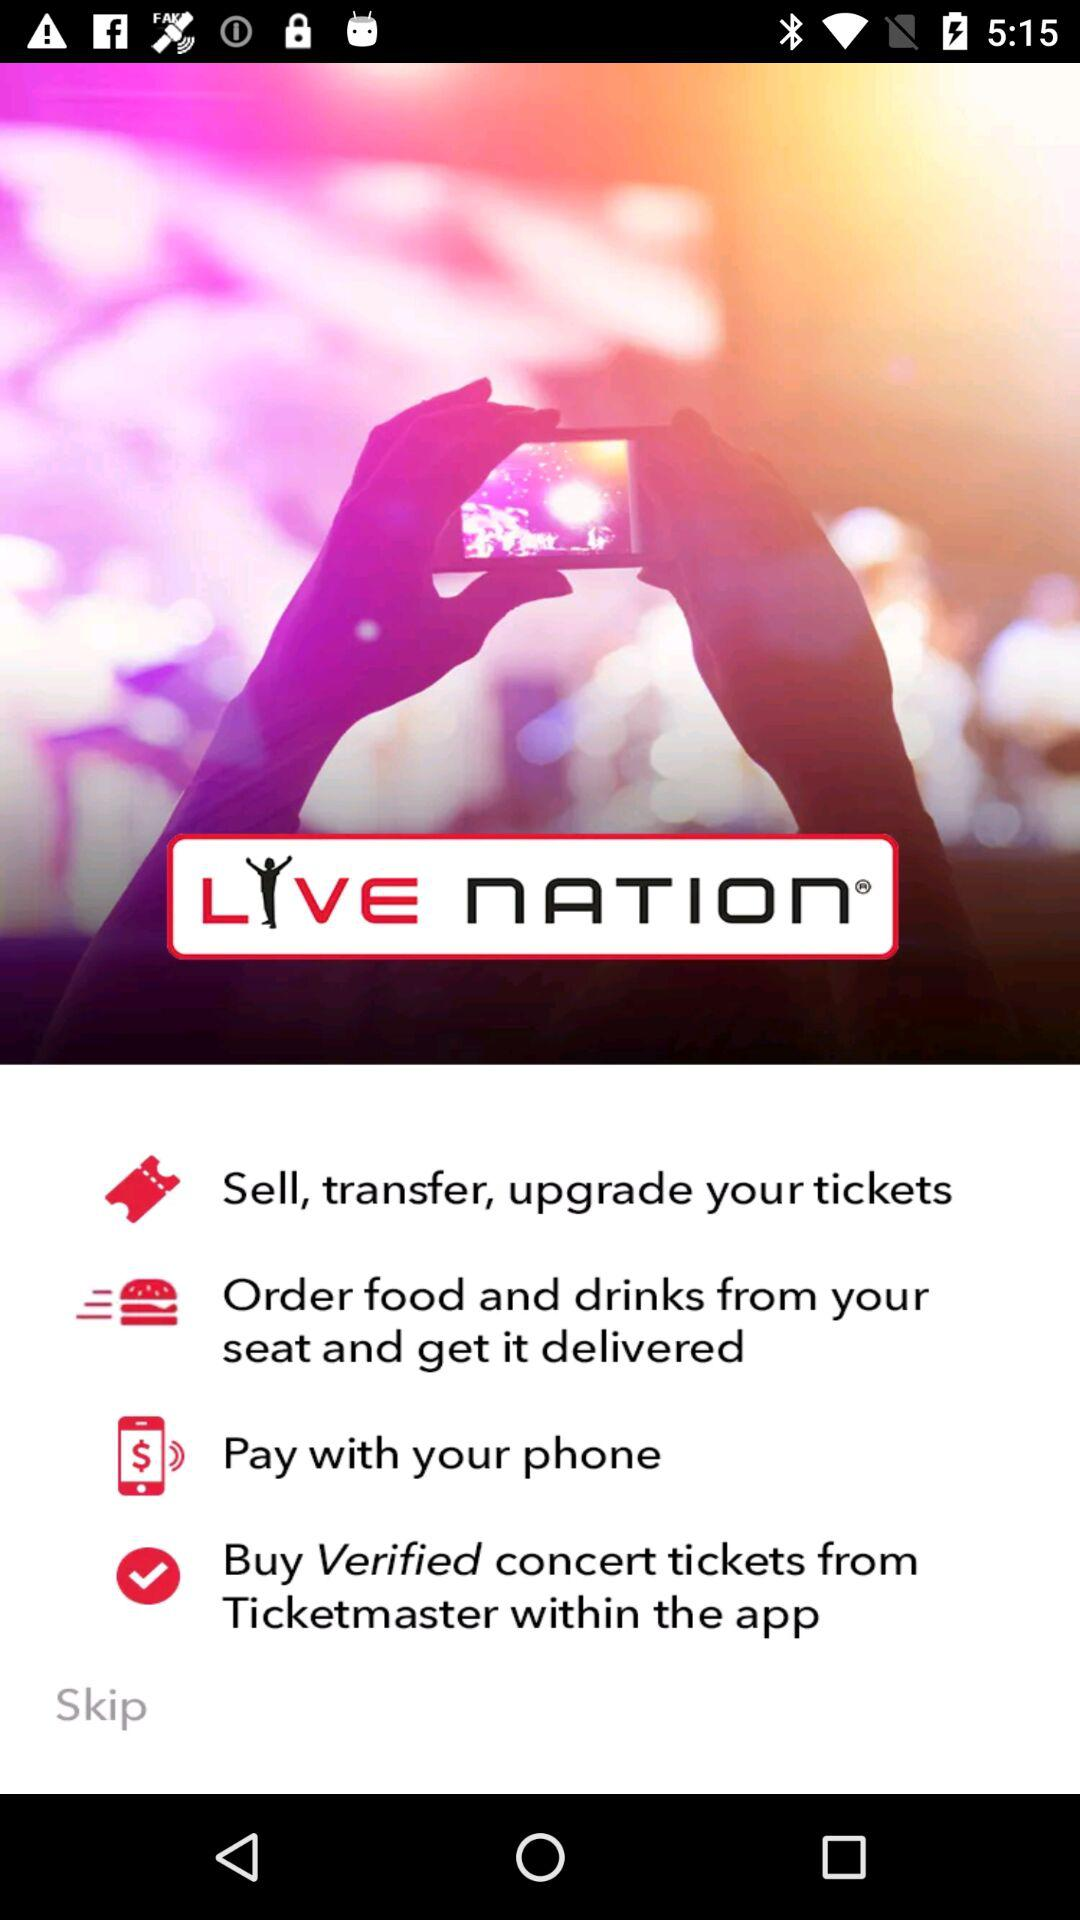What is the name of the application? The name of the application is "LIVE NATION". 